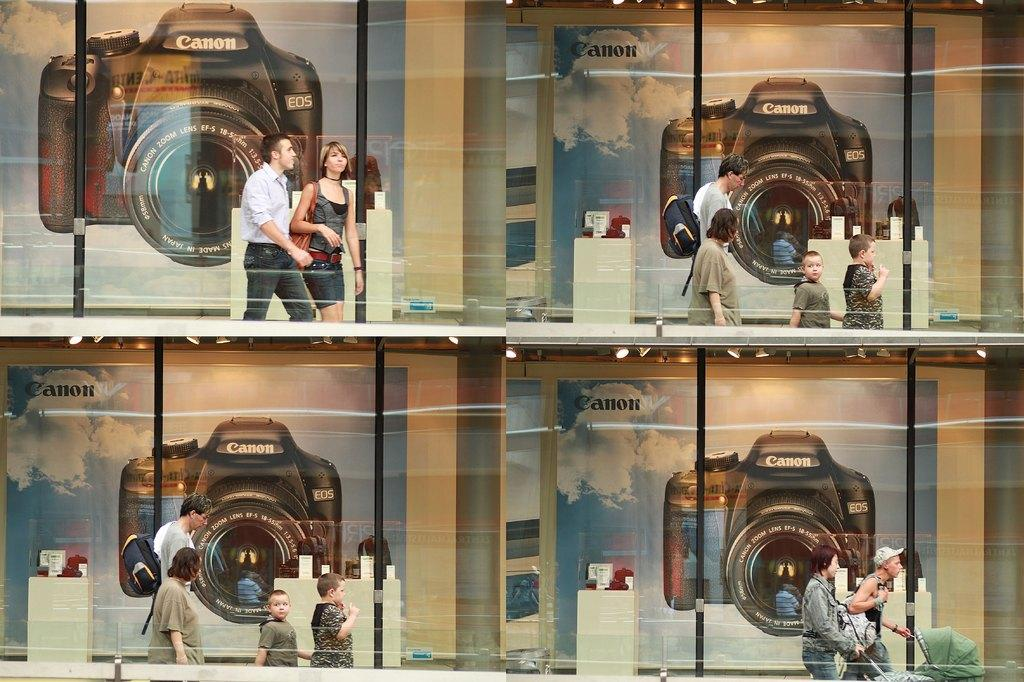What type of image is being described? The image is a collage. What can be seen in the background of the collage? There are posters of a camera in the background of the image. Who or what is present in the image? There are people in the image. What type of cave can be seen in the image? There is no cave present in the image. 